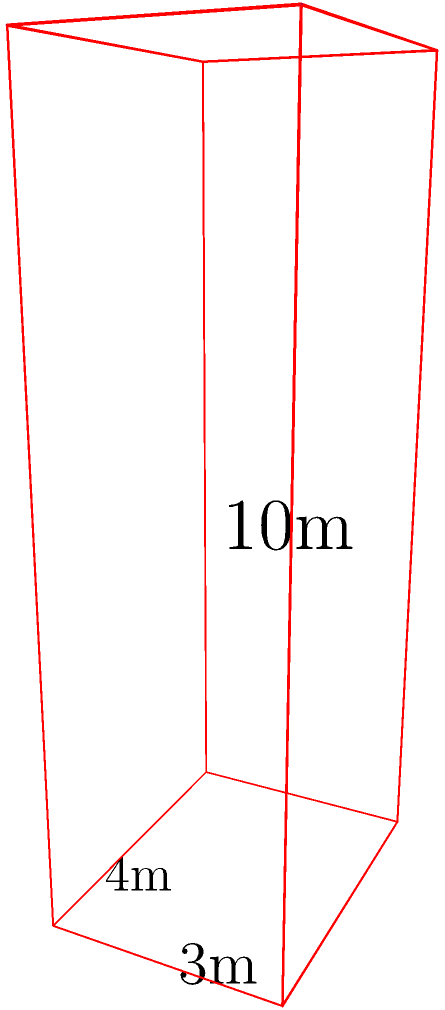A typical Spanish apartment building in Costa del Sol resembles a rectangular prism. If the building measures 4 meters wide, 3 meters deep, and 10 meters tall, what is the total surface area of the building's exterior, excluding the bottom face? Let's approach this step-by-step:

1) The building is a rectangular prism with dimensions:
   Width (w) = 4m
   Depth (d) = 3m
   Height (h) = 10m

2) We need to calculate the area of 5 faces (excluding the bottom):
   - Front and back faces (2)
   - Left and right faces (2)
   - Top face (1)

3) Area of front and back faces:
   $$A_{front/back} = w \times h = 4m \times 10m = 40m^2$$
   There are two of these, so: $$2 \times 40m^2 = 80m^2$$

4) Area of left and right faces:
   $$A_{left/right} = d \times h = 3m \times 10m = 30m^2$$
   There are two of these, so: $$2 \times 30m^2 = 60m^2$$

5) Area of top face:
   $$A_{top} = w \times d = 4m \times 3m = 12m^2$$

6) Total surface area:
   $$A_{total} = A_{front/back} + A_{left/right} + A_{top}$$
   $$A_{total} = 80m^2 + 60m^2 + 12m^2 = 152m^2$$

Therefore, the total surface area of the building's exterior, excluding the bottom face, is 152 square meters.
Answer: 152 m² 